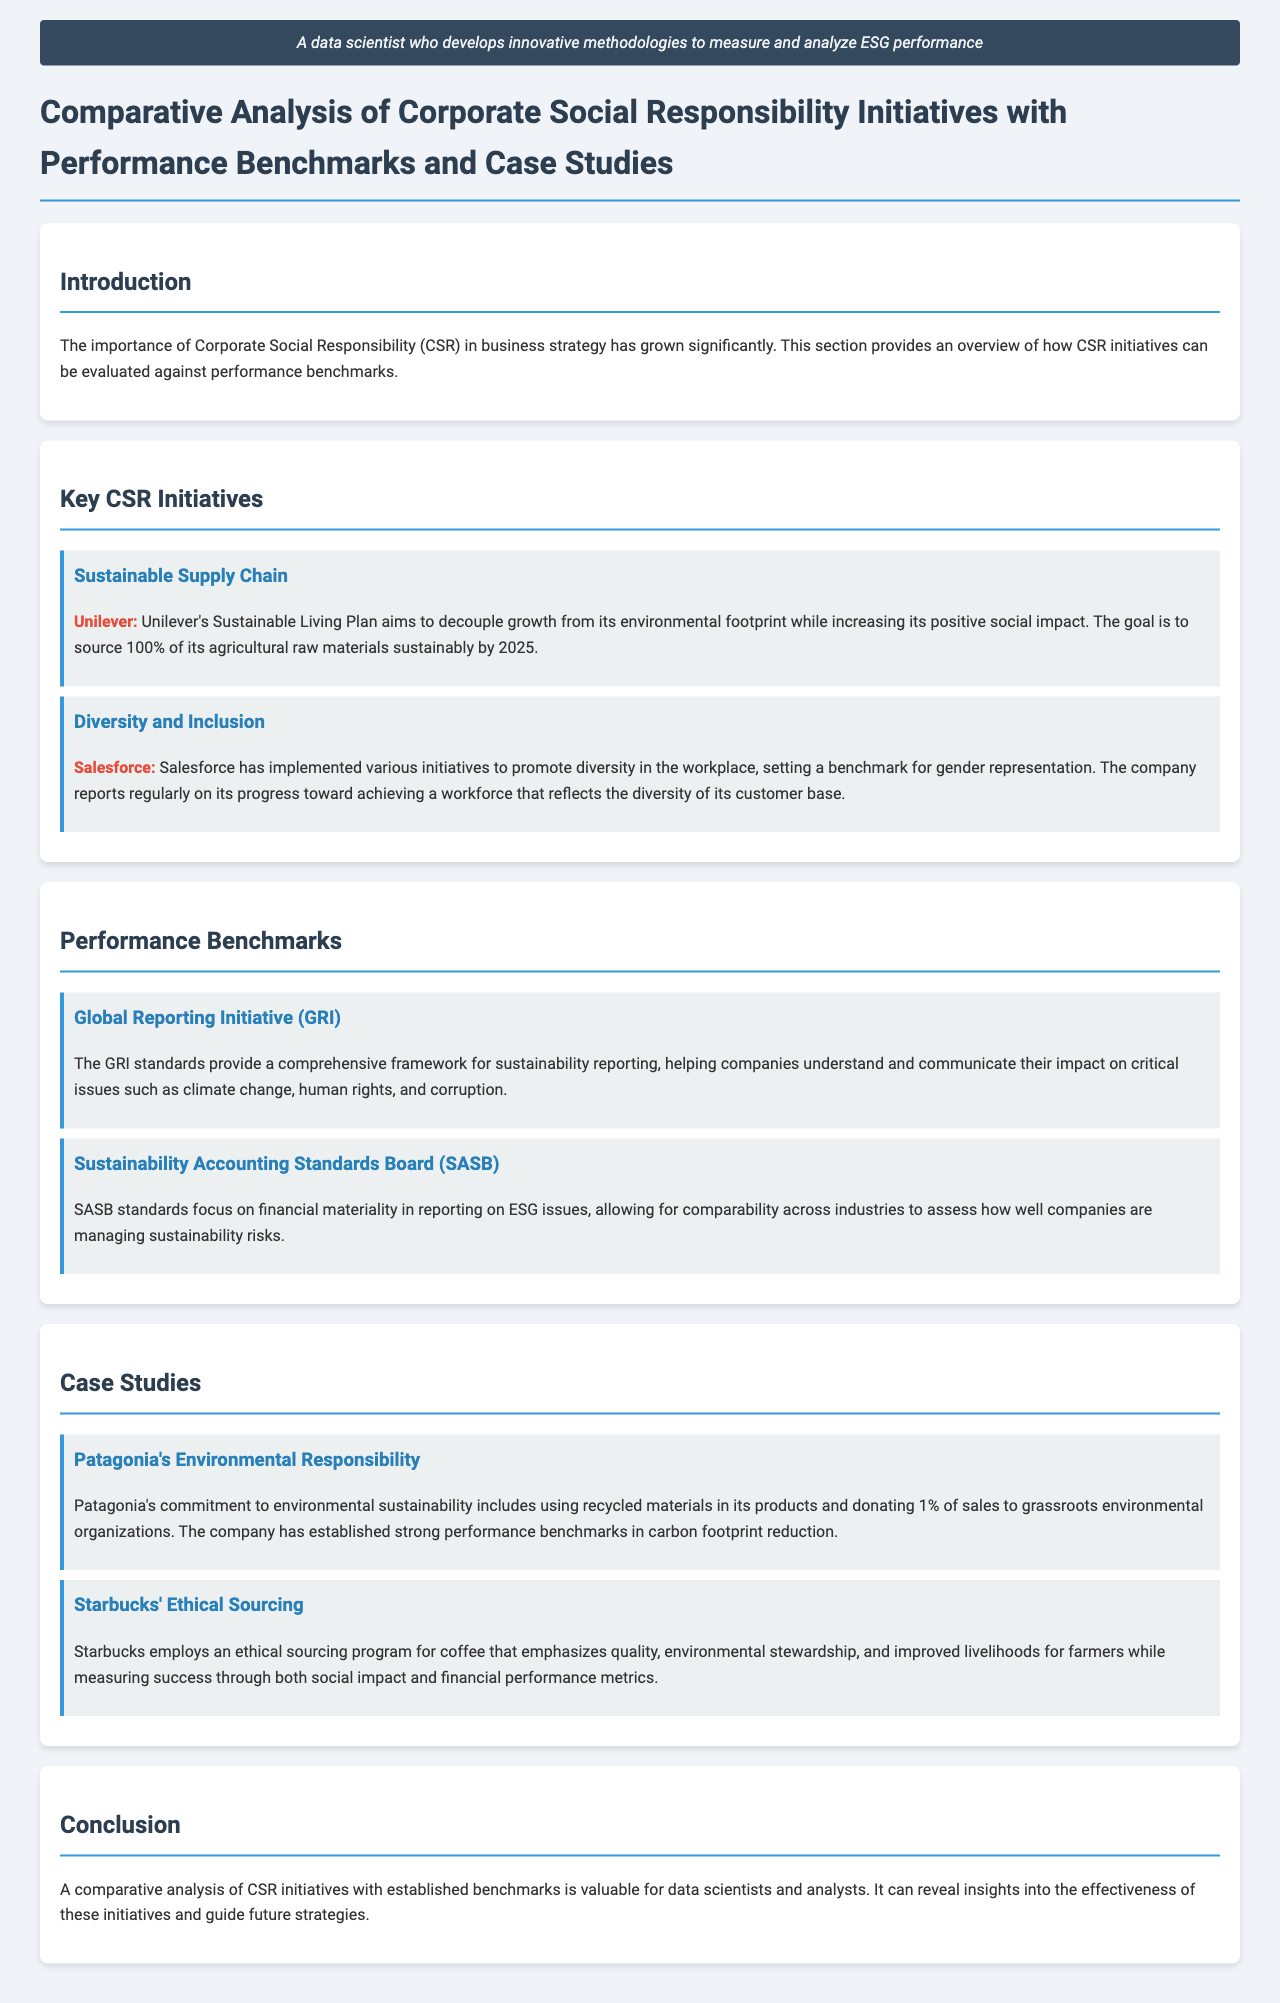what is Unilever's Sustainable Living Plan aiming for? Unilever's Sustainable Living Plan aims to decouple growth from its environmental footprint while increasing its positive social impact and to source 100% of its agricultural raw materials sustainably by 2025.
Answer: source 100% sustainably by 2025 what is the focus of SASB standards? SASB standards focus on financial materiality in reporting on ESG issues, allowing for comparability across industries to assess sustainability risks.
Answer: financial materiality which company reports on diversity in the workplace? Salesforce has implemented various initiatives to promote diversity in the workplace and reports regularly on its progress.
Answer: Salesforce how much does Patagonia donate to environmental organizations? Patagonia donates 1% of sales to grassroots environmental organizations.
Answer: 1% what is the framework provided by the GRI standards? The GRI standards provide a comprehensive framework for sustainability reporting, helping companies understand and communicate their impact on critical issues.
Answer: sustainability reporting which case study highlights ethical sourcing in coffee? Starbucks' ethical sourcing program emphasizes quality, environmental stewardship, and improved livelihoods for farmers.
Answer: Starbucks' ethical sourcing program 